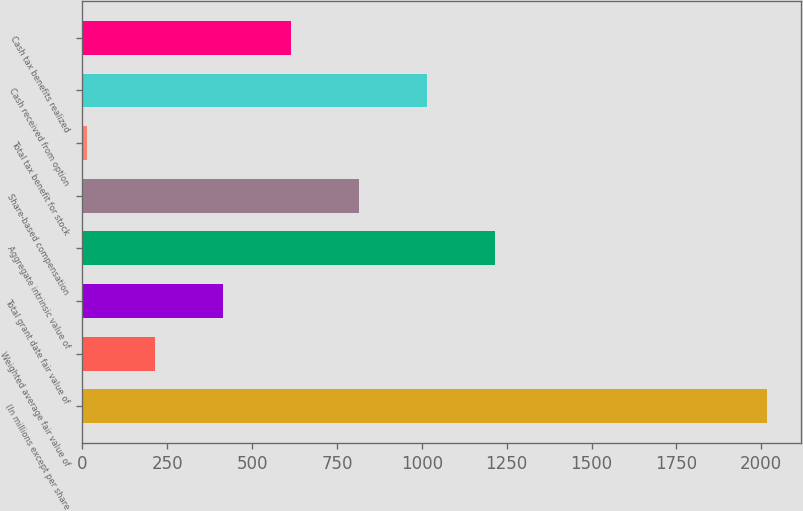<chart> <loc_0><loc_0><loc_500><loc_500><bar_chart><fcel>(In millions except per share<fcel>Weighted average fair value of<fcel>Total grant date fair value of<fcel>Aggregate intrinsic value of<fcel>Share-based compensation<fcel>Total tax benefit for stock<fcel>Cash received from option<fcel>Cash tax benefits realized<nl><fcel>2016<fcel>213.3<fcel>413.6<fcel>1214.8<fcel>814.2<fcel>13<fcel>1014.5<fcel>613.9<nl></chart> 